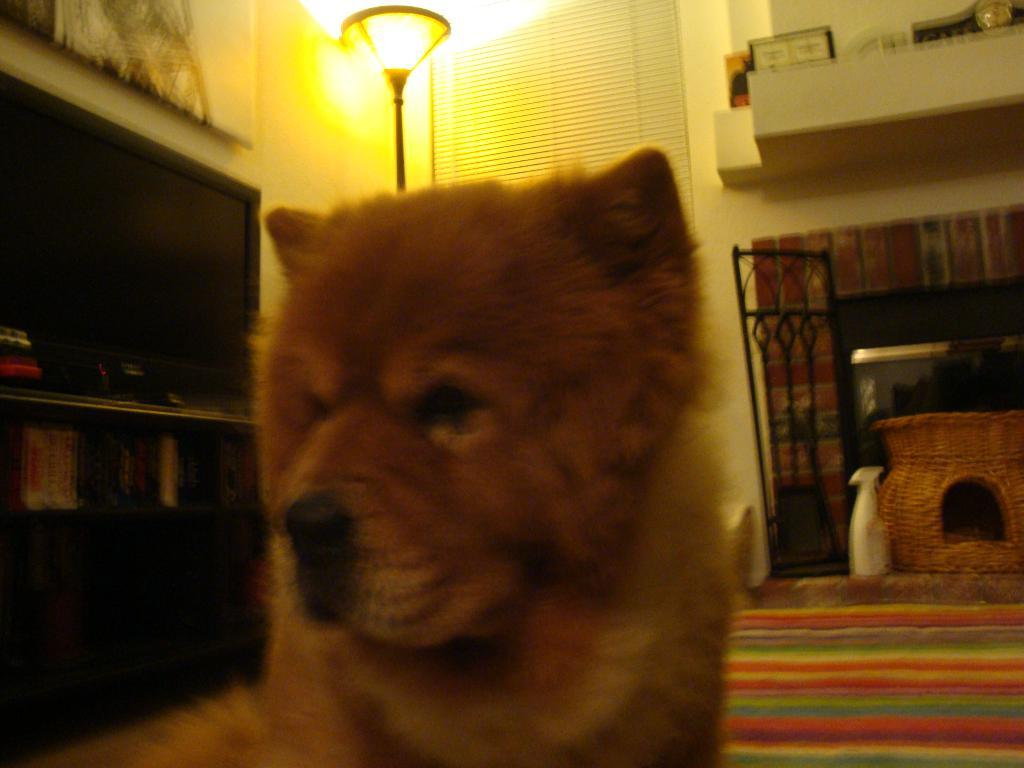What type of animal is on the ground in the image? There is a dog on the ground in the image. What can be seen in the background of the image? There are lights, windows with blinds, a shelf with objects, and objects on the floor in the background of the image. What type of hole can be seen in the dog's chin in the image? There is no hole in the dog's chin in the image, nor is there any indication of a chin. 